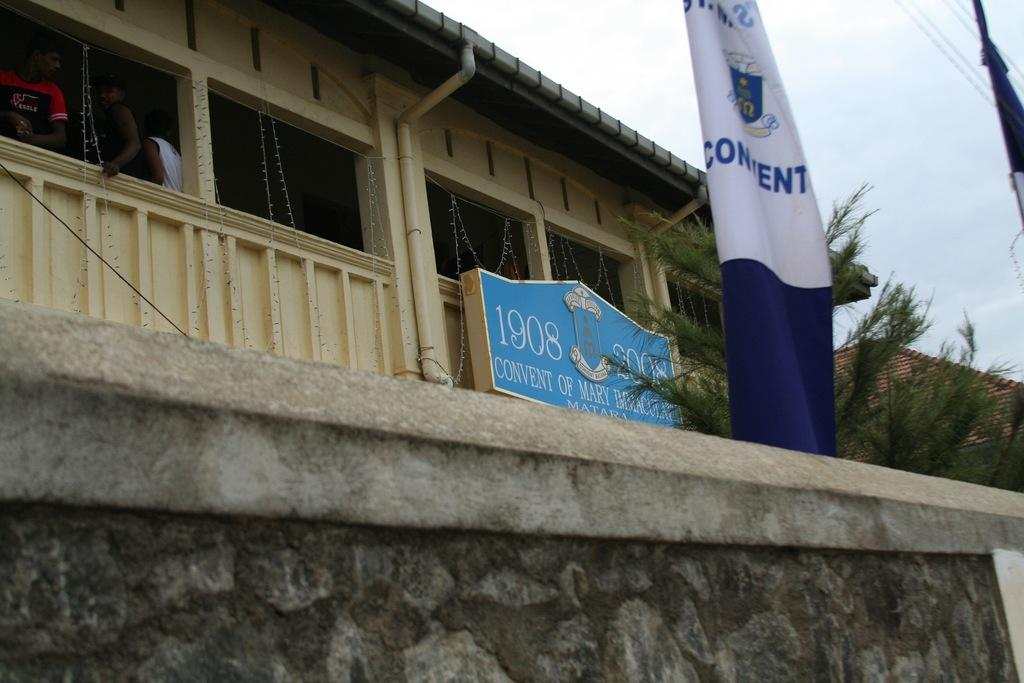What is located at the bottom side of the image? There is a wall at the bottom side of the image. What type of structures can be seen in the image? There are houses in the image. What type of vegetation is present in the image? There is a tree in the image. What additional object can be seen in the image? There is a poster in the image. What symbol is present in the image? There is a flag in the image. What is located in the top right side of the image? There are wires in the top right side of the image. What type of wood is the rabbit chewing on in the image? There is no rabbit present in the image, and therefore no wood for it to chew on. What message does the peace sign on the poster convey in the image? There is no peace sign mentioned in the provided facts, so we cannot determine the message it conveys. 